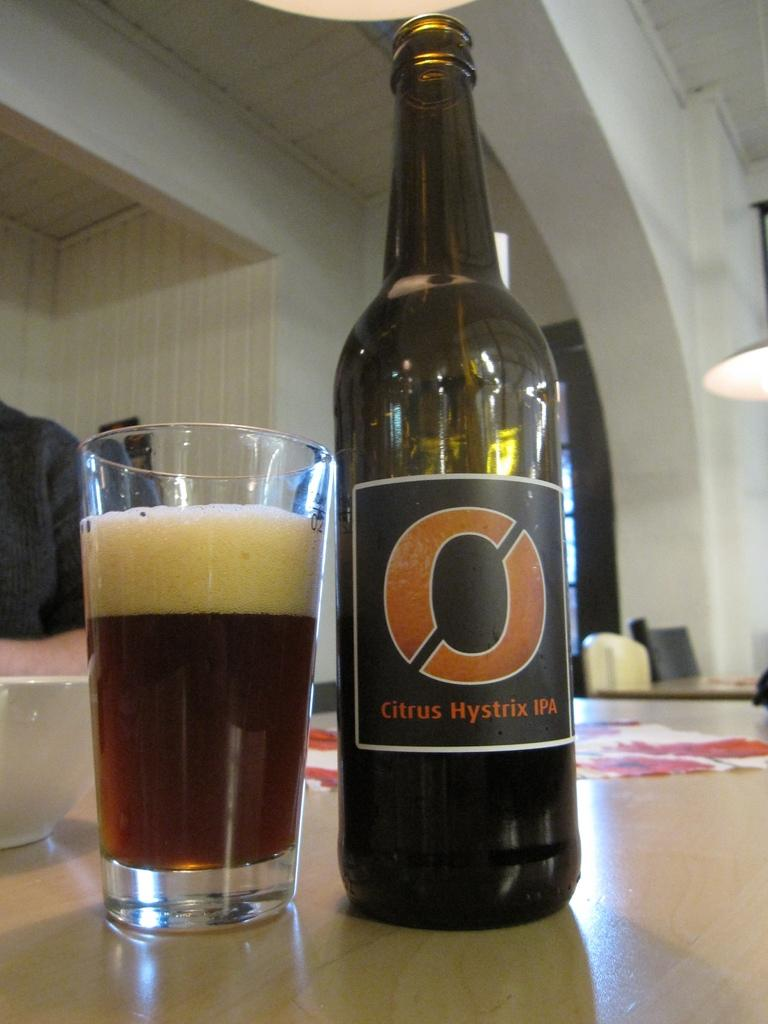<image>
Share a concise interpretation of the image provided. the letter O is on a wine bottle 